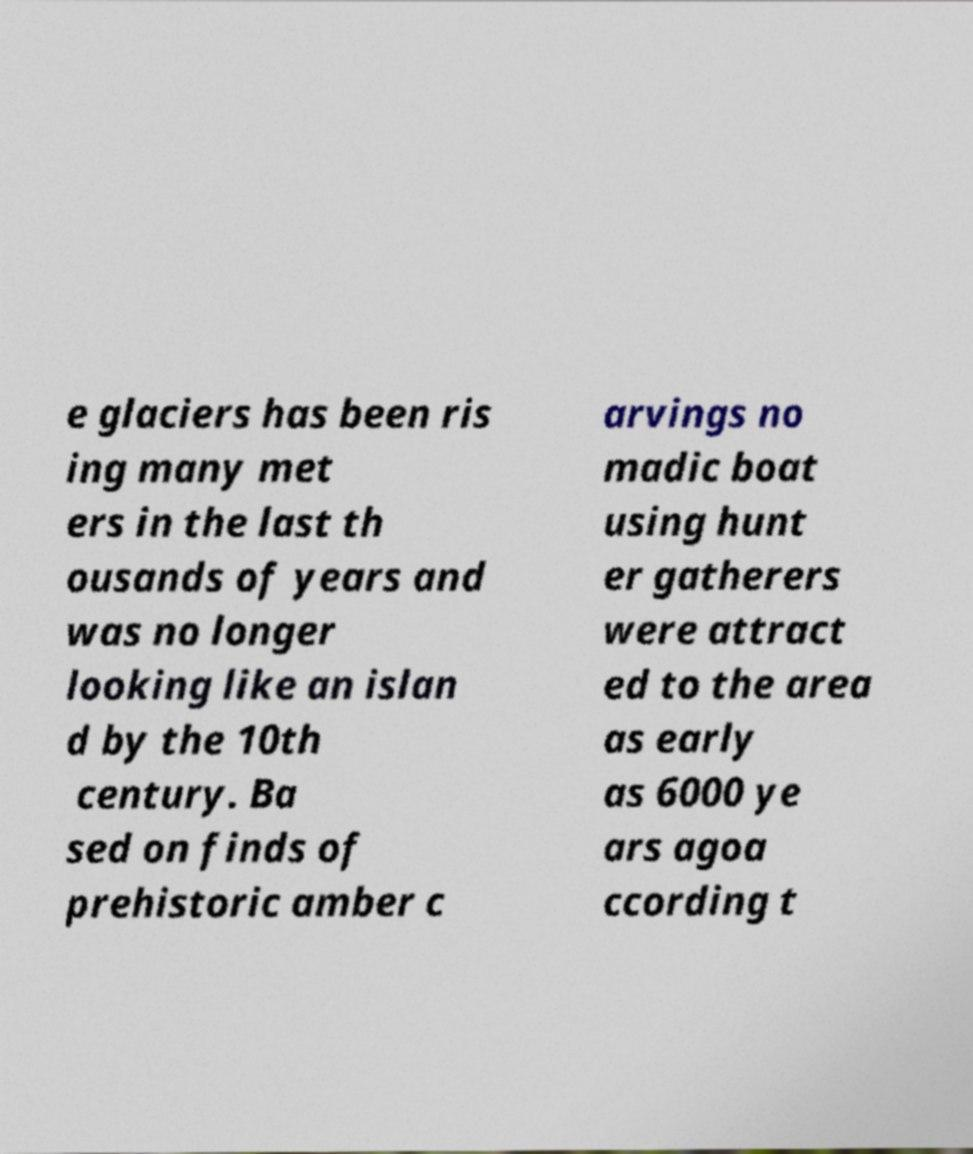Can you accurately transcribe the text from the provided image for me? e glaciers has been ris ing many met ers in the last th ousands of years and was no longer looking like an islan d by the 10th century. Ba sed on finds of prehistoric amber c arvings no madic boat using hunt er gatherers were attract ed to the area as early as 6000 ye ars agoa ccording t 